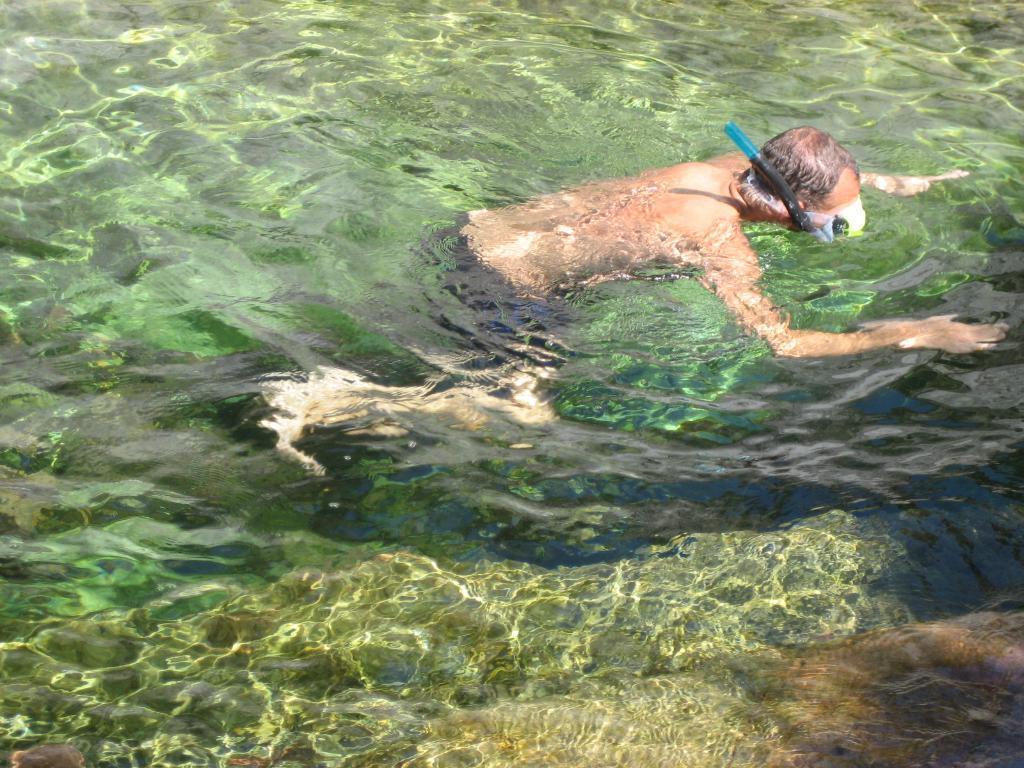Describe this image in one or two sentences. In this image there is a person swimming in the water. 